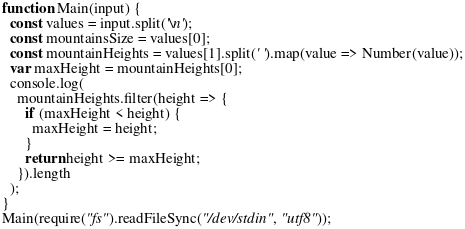<code> <loc_0><loc_0><loc_500><loc_500><_JavaScript_>function Main(input) {
  const values = input.split('\n');
  const mountainsSize = values[0];
  const mountainHeights = values[1].split(' ').map(value => Number(value));
  var maxHeight = mountainHeights[0];
  console.log(
    mountainHeights.filter(height => {
      if (maxHeight < height) {
        maxHeight = height;
      }
      return height >= maxHeight;
    }).length
  );
}
Main(require("fs").readFileSync("/dev/stdin", "utf8"));
</code> 